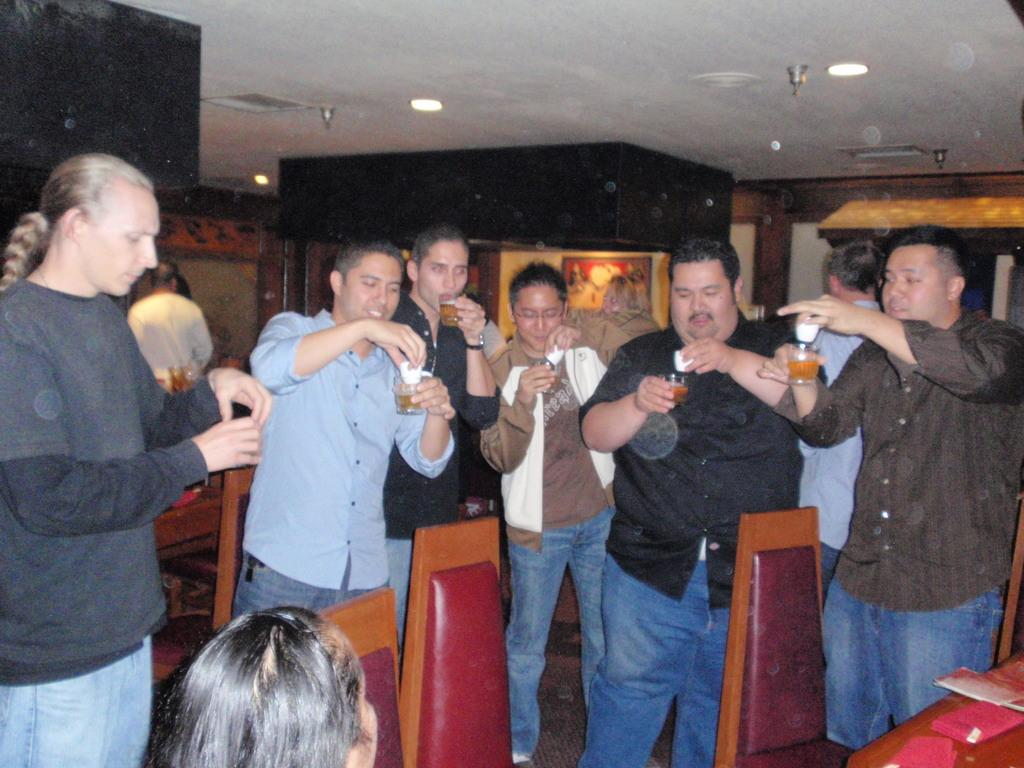Where was the image taken? The image was taken inside a room. What are the people in the image doing? The persons in the middle of the image are holding glasses. What can be seen at the top of the image? There are lights visible at the top of the image. What type of net is being used by the persons in the image? There is no net present in the image; the persons are holding glasses. Can you see any chickens in the image? No, there are no chickens present in the image. 